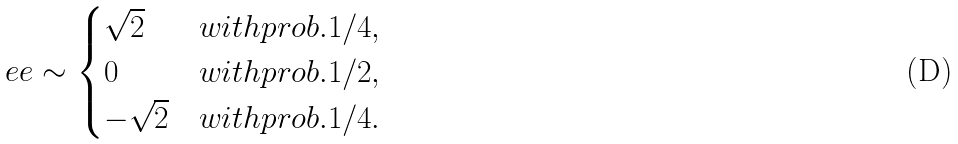<formula> <loc_0><loc_0><loc_500><loc_500>\ e e \sim \begin{cases} \sqrt { 2 } & w i t h p r o b . 1 / 4 , \\ 0 & w i t h p r o b . 1 / 2 , \\ - \sqrt { 2 } & w i t h p r o b . 1 / 4 . \end{cases}</formula> 